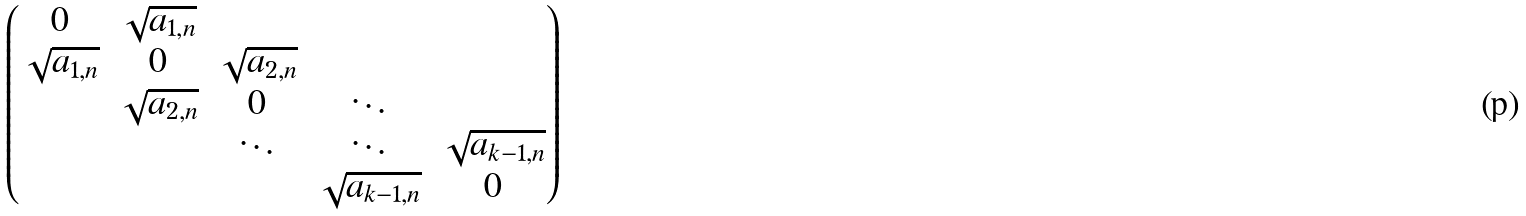Convert formula to latex. <formula><loc_0><loc_0><loc_500><loc_500>\begin{pmatrix} 0 & \sqrt { a _ { 1 , n } } & & & \\ \sqrt { a _ { 1 , n } } & 0 & \sqrt { a _ { 2 , n } } & & \\ & \sqrt { a _ { 2 , n } } & 0 & \ddots & \\ & & \ddots & \ddots & \sqrt { a _ { k - 1 , n } } \\ & & & \sqrt { a _ { k - 1 , n } } & 0 \end{pmatrix}</formula> 